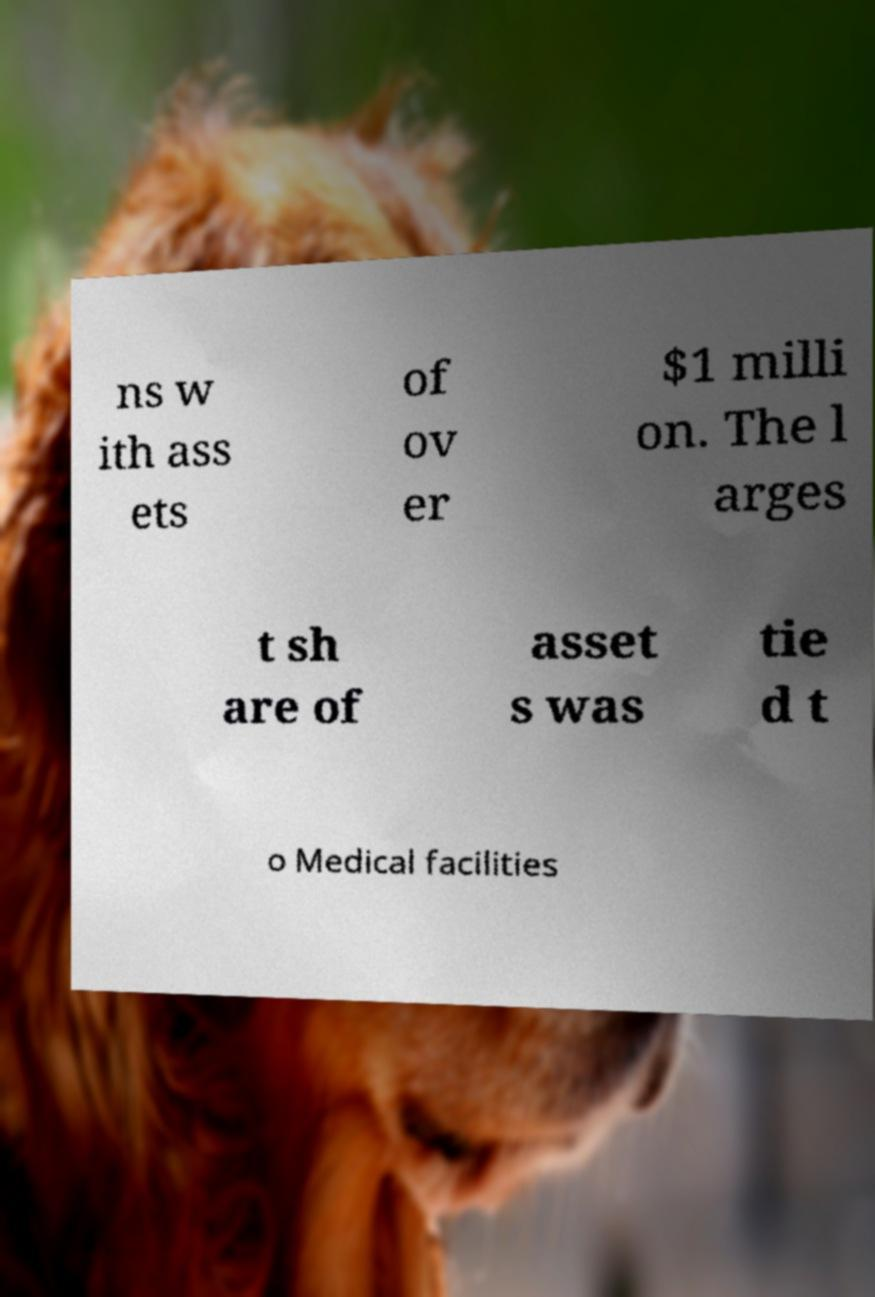Please identify and transcribe the text found in this image. ns w ith ass ets of ov er $1 milli on. The l arges t sh are of asset s was tie d t o Medical facilities 